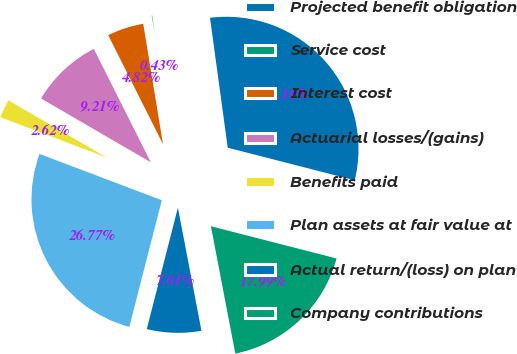<chart> <loc_0><loc_0><loc_500><loc_500><pie_chart><fcel>Projected benefit obligation<fcel>Service cost<fcel>Interest cost<fcel>Actuarial losses/(gains)<fcel>Benefits paid<fcel>Plan assets at fair value at<fcel>Actual return/(loss) on plan<fcel>Company contributions<nl><fcel>31.16%<fcel>0.43%<fcel>4.82%<fcel>9.21%<fcel>2.62%<fcel>26.77%<fcel>7.01%<fcel>17.99%<nl></chart> 